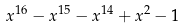<formula> <loc_0><loc_0><loc_500><loc_500>x ^ { 1 6 } - x ^ { 1 5 } - x ^ { 1 4 } + x ^ { 2 } - 1</formula> 